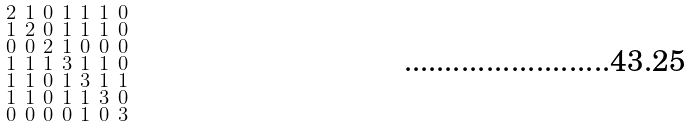Convert formula to latex. <formula><loc_0><loc_0><loc_500><loc_500>\begin{smallmatrix} 2 & 1 & 0 & 1 & 1 & 1 & 0 \\ 1 & 2 & 0 & 1 & 1 & 1 & 0 \\ 0 & 0 & 2 & 1 & 0 & 0 & 0 \\ 1 & 1 & 1 & 3 & 1 & 1 & 0 \\ 1 & 1 & 0 & 1 & 3 & 1 & 1 \\ 1 & 1 & 0 & 1 & 1 & 3 & 0 \\ 0 & 0 & 0 & 0 & 1 & 0 & 3 \end{smallmatrix}</formula> 